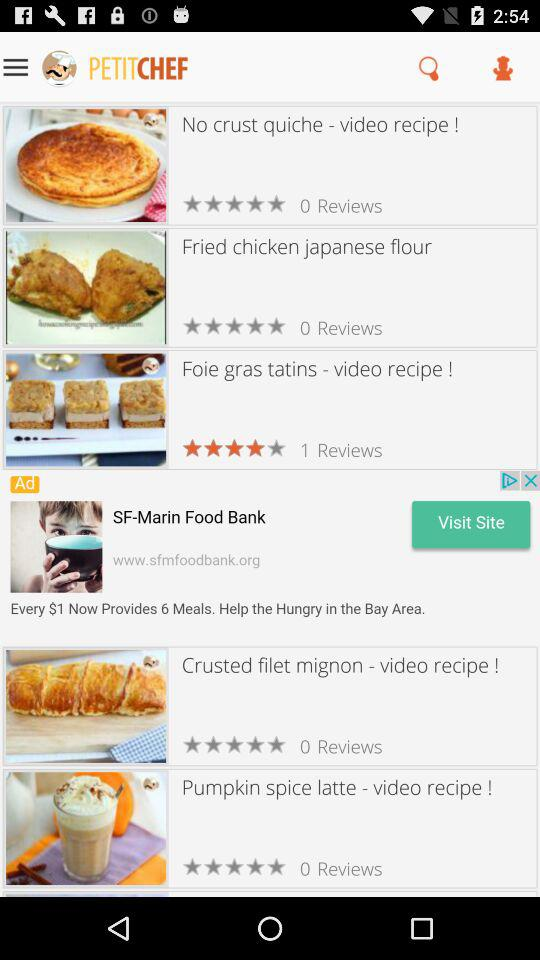Which menu item is selected?
When the provided information is insufficient, respond with <no answer>. <no answer> 